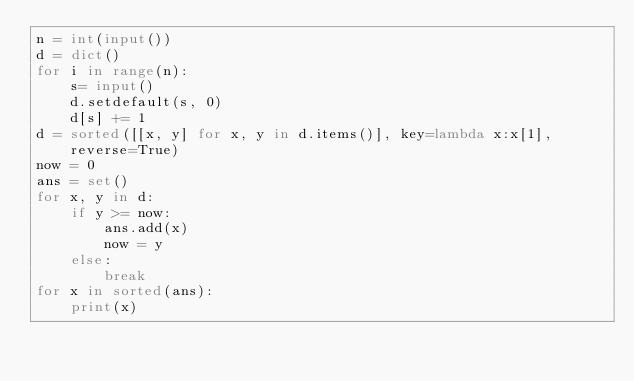<code> <loc_0><loc_0><loc_500><loc_500><_Python_>n = int(input())
d = dict()
for i in range(n):
    s= input()
    d.setdefault(s, 0)
    d[s] += 1
d = sorted([[x, y] for x, y in d.items()], key=lambda x:x[1], reverse=True)
now = 0
ans = set()
for x, y in d:
    if y >= now:
        ans.add(x)
        now = y
    else:
        break
for x in sorted(ans):
    print(x)</code> 